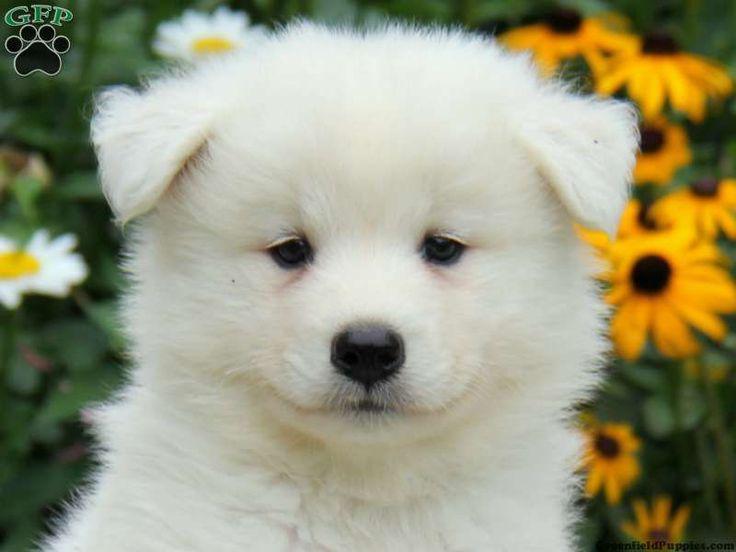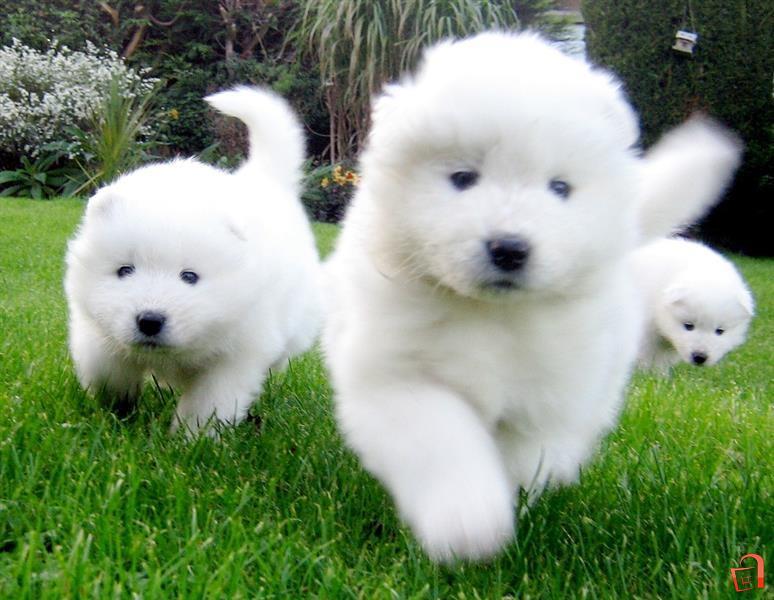The first image is the image on the left, the second image is the image on the right. Analyze the images presented: Is the assertion "One image contains exactly two dogs side-by-side, and the other features one non-standing dog." valid? Answer yes or no. No. 